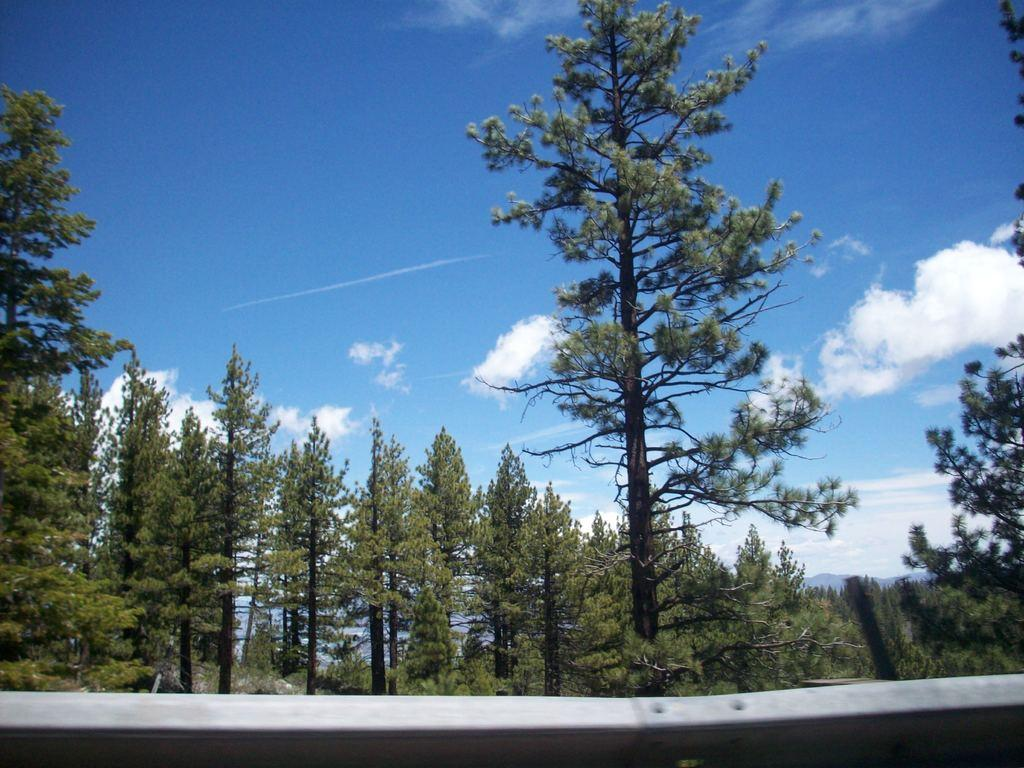What type of vegetation can be seen in the image? There are trees in the image. What part of the natural environment is visible in the image? The sky is visible in the image. What can be observed in the sky? Clouds are present in the sky. What material is the object at the bottom of the image made of? The object at the bottom of the image is metallic. Can you see a snail crawling on the trees in the image? There is no snail visible on the trees in the image. Is there a person flying a kite in the sky? There is no person or kite present in the image. 